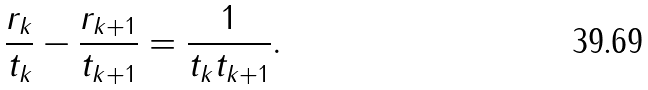<formula> <loc_0><loc_0><loc_500><loc_500>\frac { r _ { k } } { t _ { k } } - \frac { r _ { k + 1 } } { t _ { k + 1 } } = \frac { 1 } { t _ { k } t _ { k + 1 } } .</formula> 